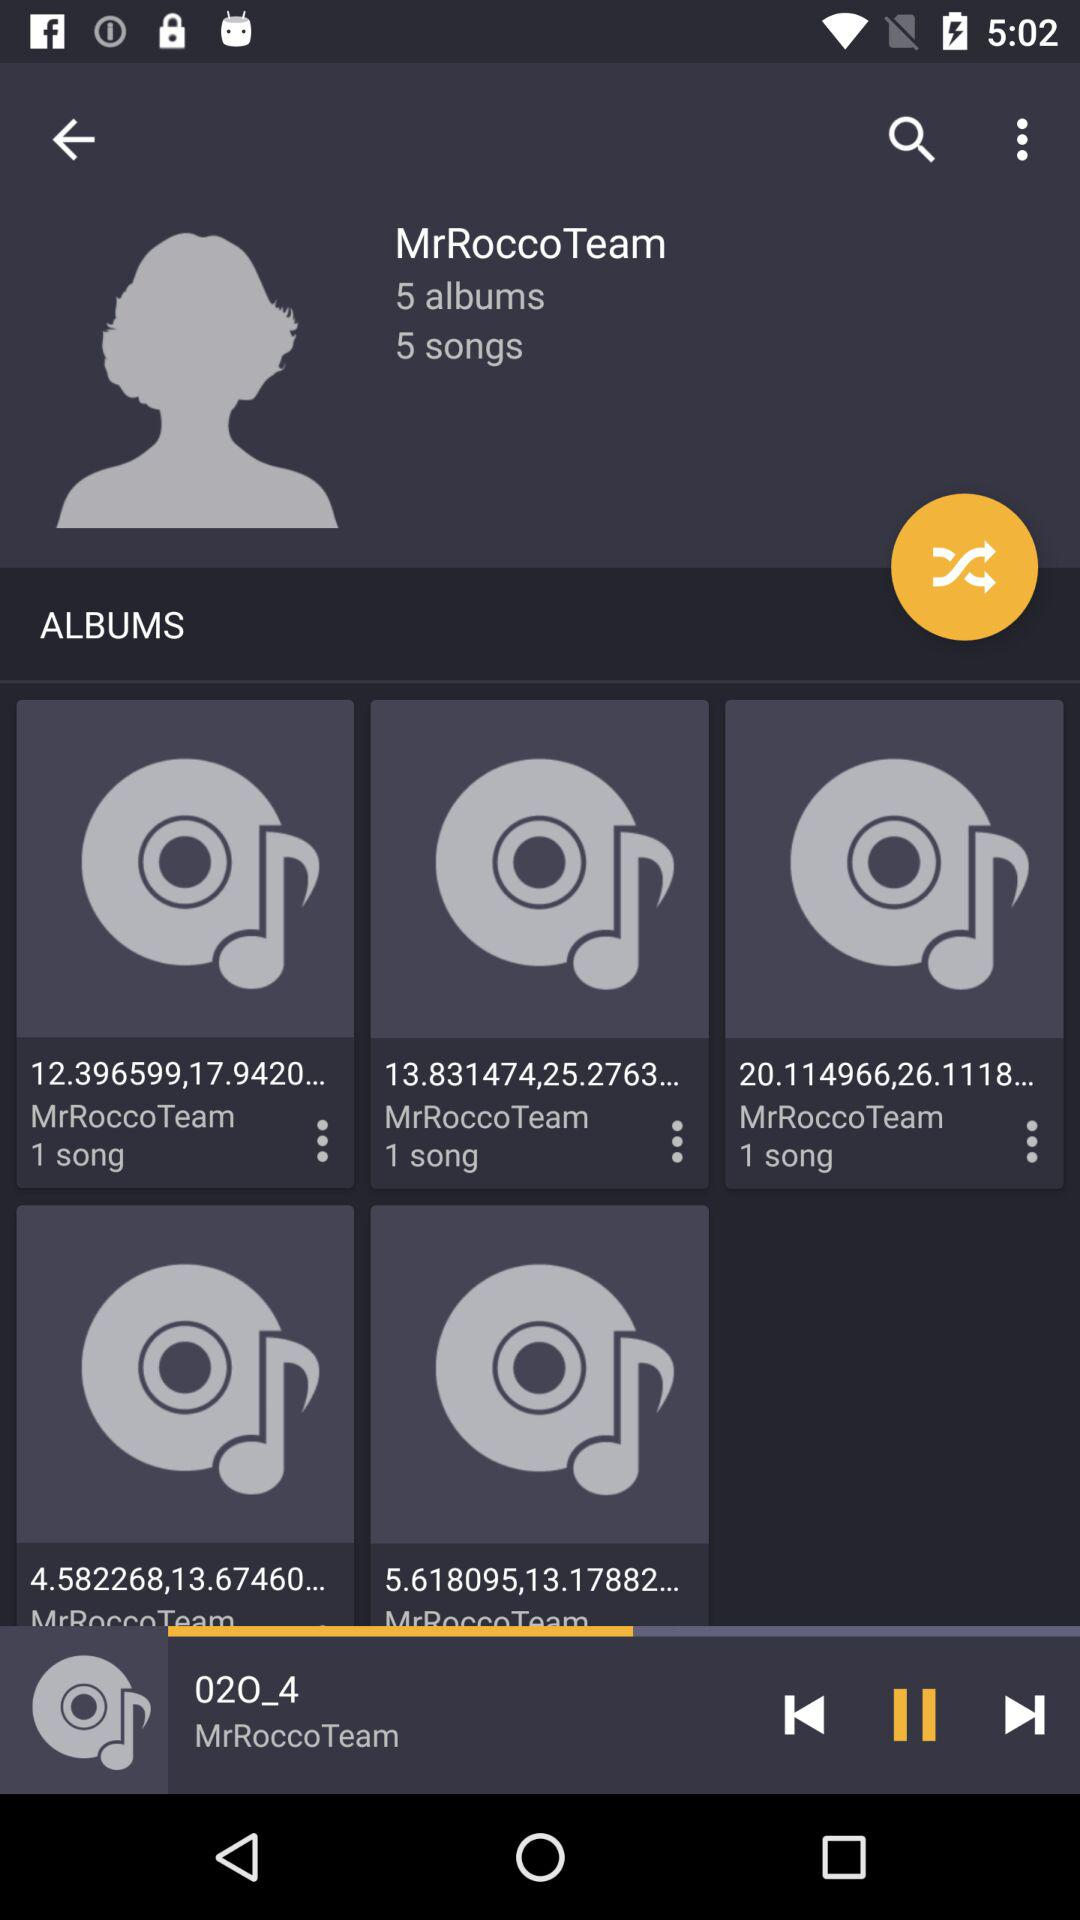Can we shuffle yhe playlist?
When the provided information is insufficient, respond with <no answer>. <no answer> 